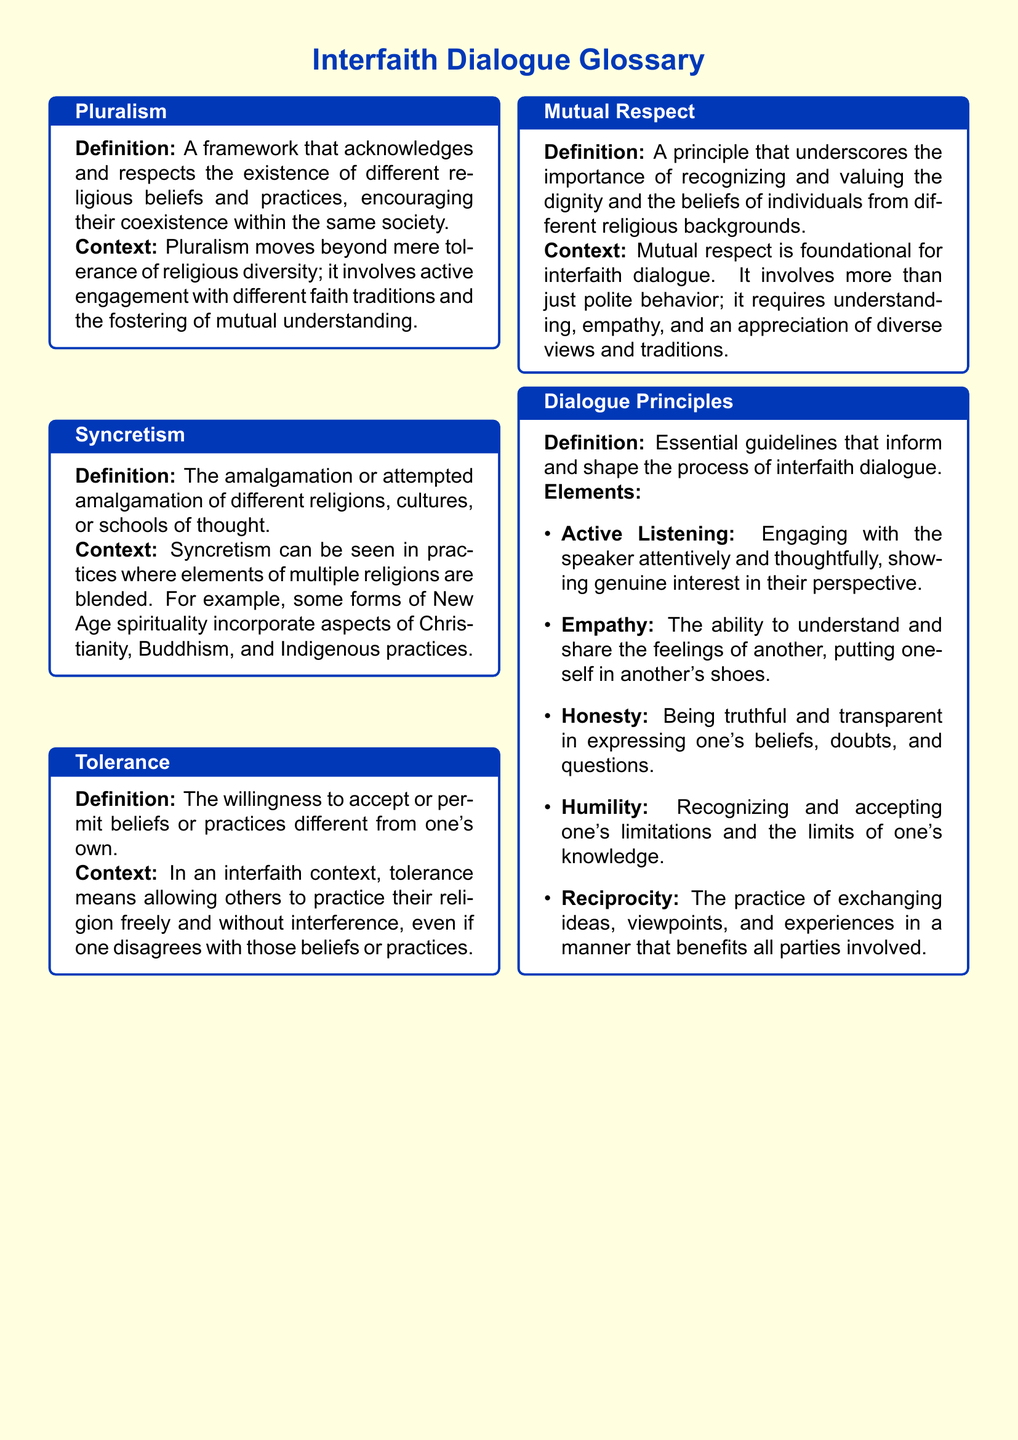What is the definition of pluralism? The definition of pluralism is provided in the glossary, stating it's a framework that acknowledges and respects the existence of different religious beliefs and practices.
Answer: A framework that acknowledges and respects the existence of different religious beliefs and practices What does syncretism involve? The context of syncretism in the document indicates it involves the amalgamation or attempted amalgamation of different religions, cultures, or schools of thought.
Answer: The amalgamation or attempted amalgamation of different religions, cultures, or schools of thought What principle underscores the importance of recognizing and valuing dignity? The document specifies that mutual respect is the principle that underscores the importance of recognizing and valuing the dignity of individuals from different religious backgrounds.
Answer: Mutual respect Which dialogue principle includes engaging with the speaker attentively? The dialogue principle that includes engaging with the speaker attentively is described as active listening in the document.
Answer: Active Listening How many elements are listed under dialogue principles? The document outlines five essential elements that inform and shape the process of interfaith dialogue.
Answer: Five What is the main context of tolerance? The context of tolerance highlighted in the document discusses the willingness to accept or permit beliefs or practices different from one's own.
Answer: The willingness to accept or permit beliefs or practices different from one's own What is required for genuine mutual respect in interfaith dialogue? The document conveys that mutual respect requires understanding, empathy, and an appreciation of diverse views and traditions.
Answer: Understanding, empathy, and an appreciation of diverse views and traditions Which term refers to the blending of multiple religions in practices? The term that refers to the blending of multiple religions in practices is syncretism.
Answer: Syncretism 